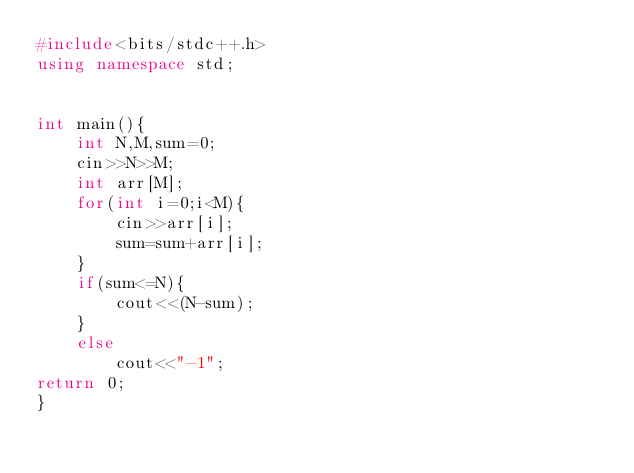<code> <loc_0><loc_0><loc_500><loc_500><_C++_>#include<bits/stdc++.h>
using namespace std;
 

int main(){
	int N,M,sum=0;
	cin>>N>>M;
	int arr[M];
	for(int i=0;i<M){
		cin>>arr[i];
		sum=sum+arr[i];
	}
	if(sum<=N){
		cout<<(N-sum);
	}
	else
		cout<<"-1";
return 0;
}
</code> 